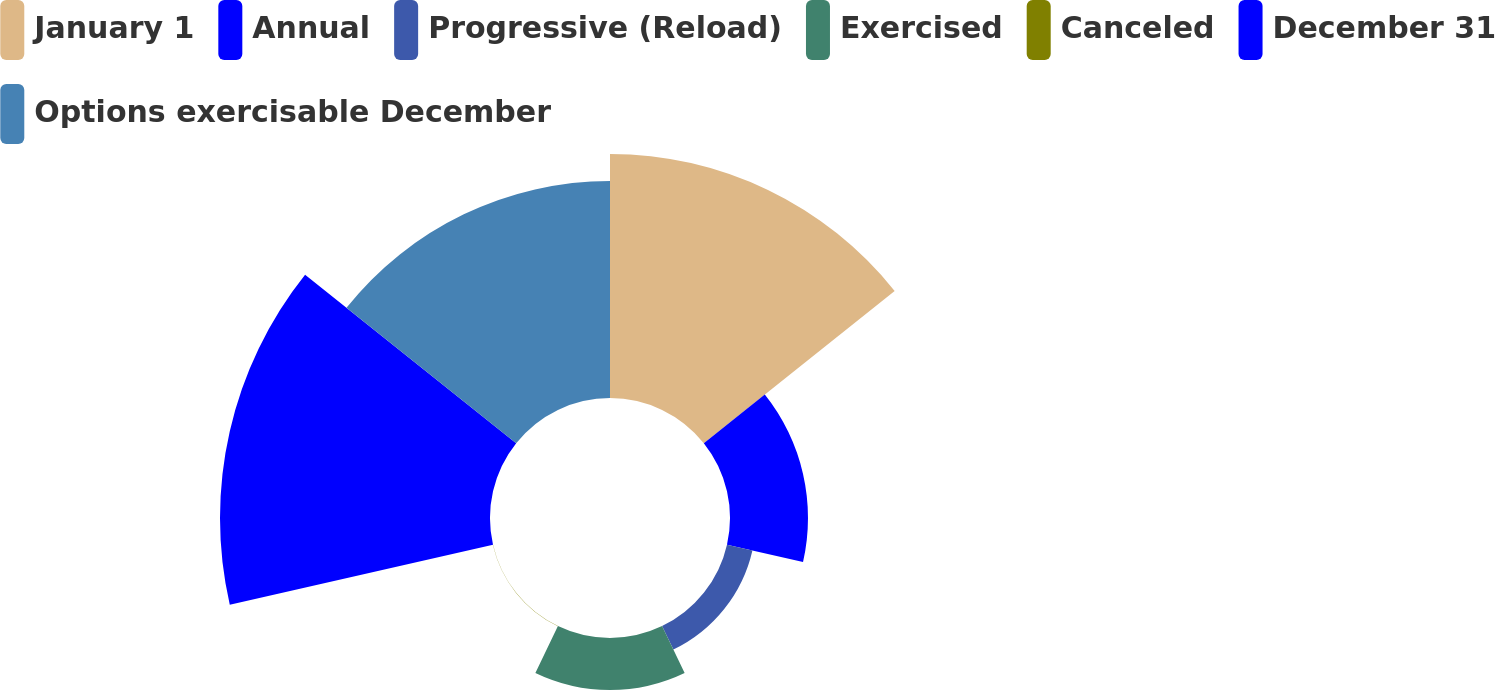Convert chart. <chart><loc_0><loc_0><loc_500><loc_500><pie_chart><fcel>January 1<fcel>Annual<fcel>Progressive (Reload)<fcel>Exercised<fcel>Canceled<fcel>December 31<fcel>Options exercisable December<nl><fcel>27.51%<fcel>8.79%<fcel>2.94%<fcel>5.86%<fcel>0.02%<fcel>30.43%<fcel>24.46%<nl></chart> 